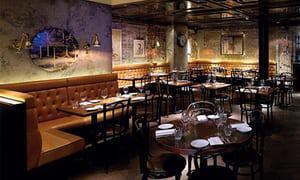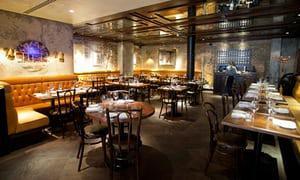The first image is the image on the left, the second image is the image on the right. Evaluate the accuracy of this statement regarding the images: "An interior of a restaurant has yellow tufted bench seating around its perimeter and has a view of a staircase glowing violet and blue above the seating on the right.". Is it true? Answer yes or no. No. The first image is the image on the left, the second image is the image on the right. For the images shown, is this caption "Each image shows an empty restaurant with no people visible." true? Answer yes or no. No. 